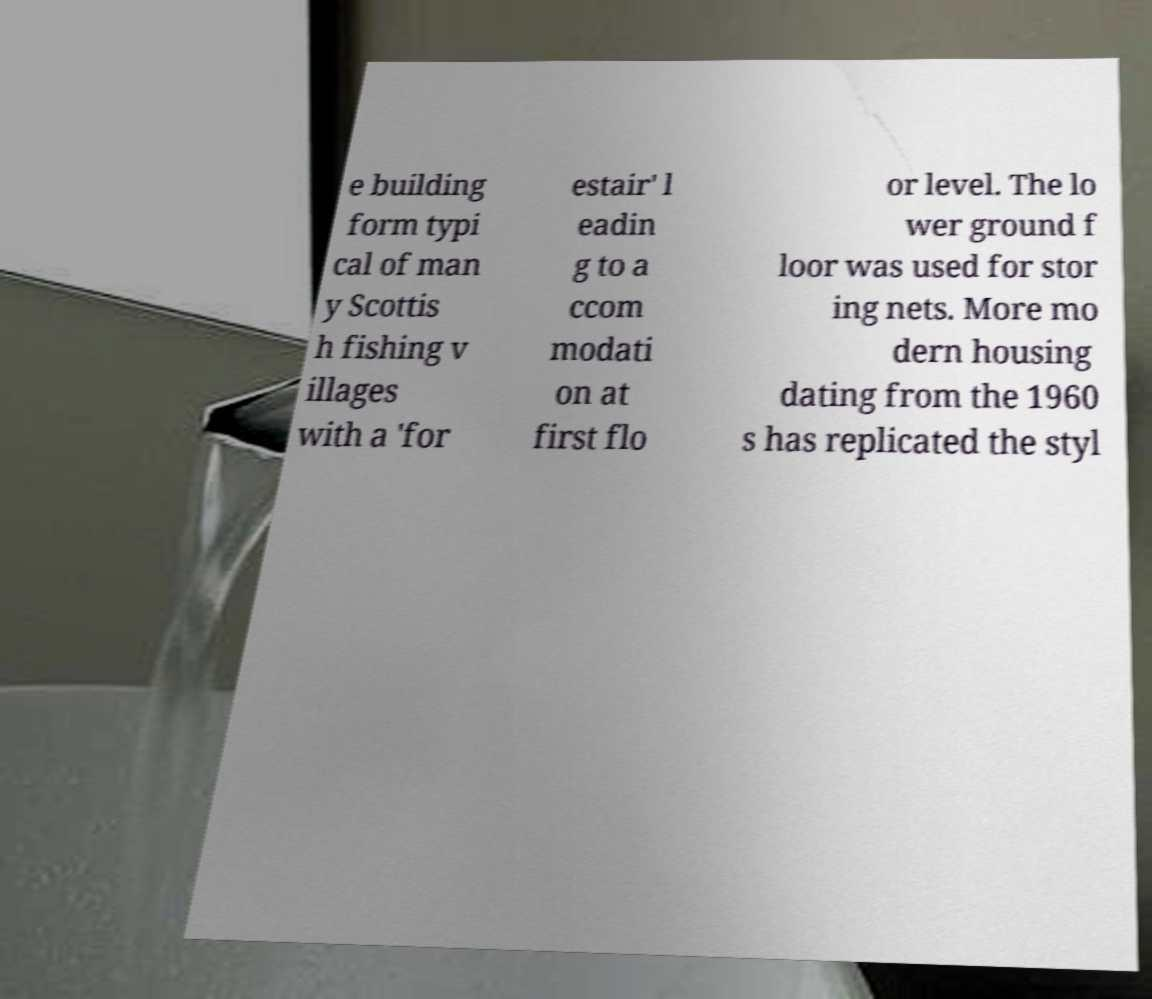I need the written content from this picture converted into text. Can you do that? e building form typi cal of man y Scottis h fishing v illages with a 'for estair' l eadin g to a ccom modati on at first flo or level. The lo wer ground f loor was used for stor ing nets. More mo dern housing dating from the 1960 s has replicated the styl 